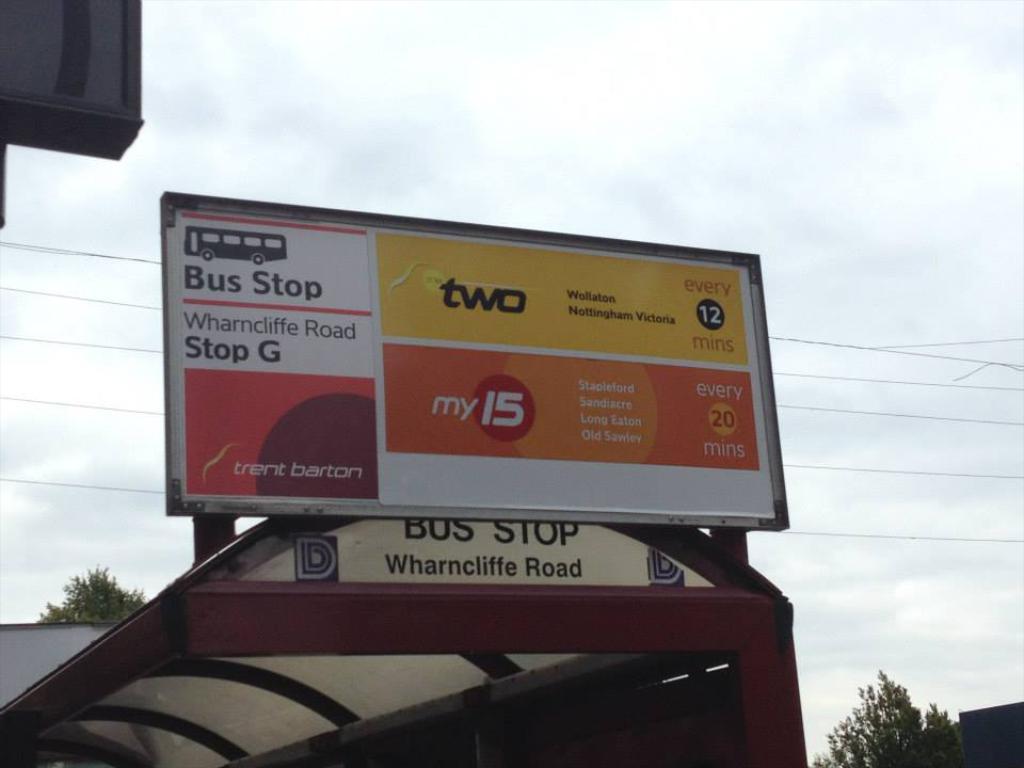What bus stop is being advertised?
Provide a short and direct response. Wharncliffe road stop g. 